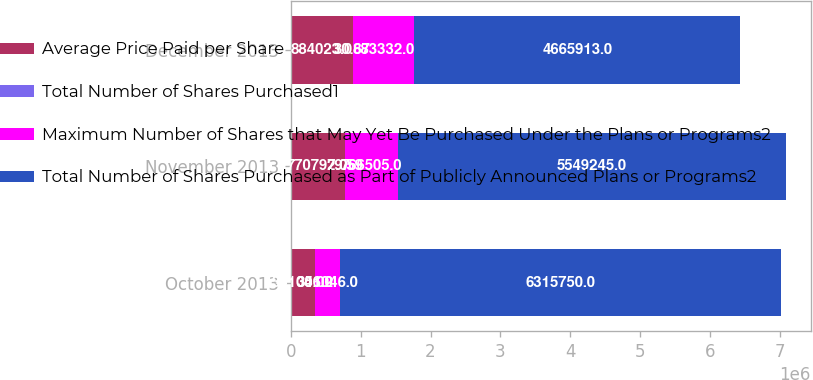Convert chart to OTSL. <chart><loc_0><loc_0><loc_500><loc_500><stacked_bar_chart><ecel><fcel>October 2013<fcel>November 2013<fcel>December 2013<nl><fcel>Average Price Paid per Share<fcel>351046<fcel>770797<fcel>884023<nl><fcel>Total Number of Shares Purchased1<fcel>30.02<fcel>29.59<fcel>30.67<nl><fcel>Maximum Number of Shares that May Yet Be Purchased Under the Plans or Programs2<fcel>351046<fcel>766505<fcel>883332<nl><fcel>Total Number of Shares Purchased as Part of Publicly Announced Plans or Programs2<fcel>6.31575e+06<fcel>5.54924e+06<fcel>4.66591e+06<nl></chart> 